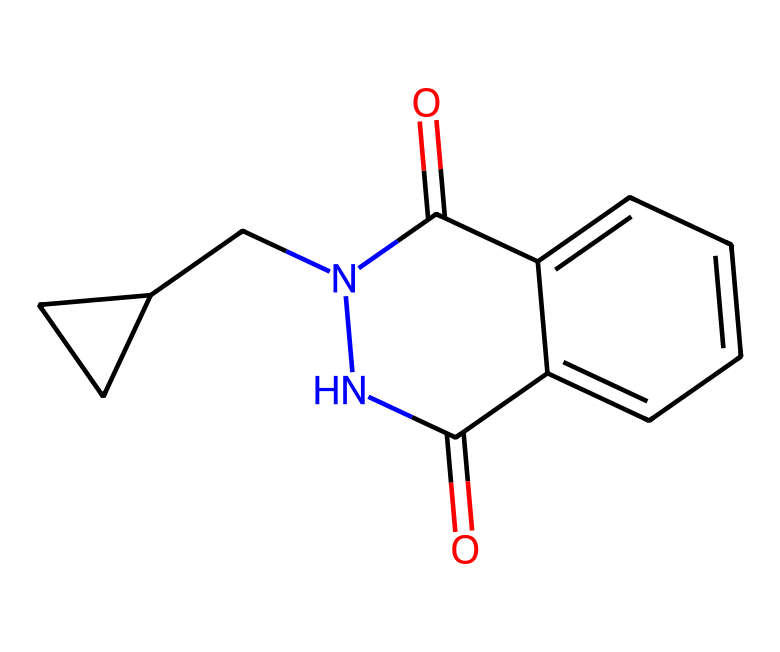How many nitrogen atoms are present in this imide? By examining the SMILES representation, we can see that there are two instances of the letter "N" which represent nitrogen atoms. This indicates that the chemical structure contains two nitrogen atoms.
Answer: 2 What type of functional groups are present in this chemical? The presence of "C(=O)" indicates that there are carbonyl groups. In imides, we typically also have nitrogen involved in the carbonyl formation. Thus, this structure reveals carbonyl and imide functional groups.
Answer: imide and carbonyl groups What is the molecular weight of this imide? Calculating from the SMILES structure, we count all the carbon, hydrogen, nitrogen, and oxygen atoms and use their respective atomic weights to find the total molecular weight. The molecular formula corresponds to a weight that sums up to approximately 255 grams per mole.
Answer: 255 grams per mole How many rings are present in this chemical structure? By examining the structure from the SMILES encoding, we identify both the presence of cyclic structures and the numbering that denotes ring closure (such as “1” and “2”). This indicates that there are two distinct rings in the molecule.
Answer: 2 What specific property of imides makes them suitable for use in car seat cushions? Imides typically exhibit good thermal stability and resistance to deformation, making them ideal for maintaining structure and comfort under the conditions present in car interiors.
Answer: thermal stability What is the primary source of the cushioning effect in this compound? The cushioning effect largely comes from the coiled or branched nature of the polymer chains derived from the imide structure, which allows for energy absorption and flexibility.
Answer: coiled polymer chains 